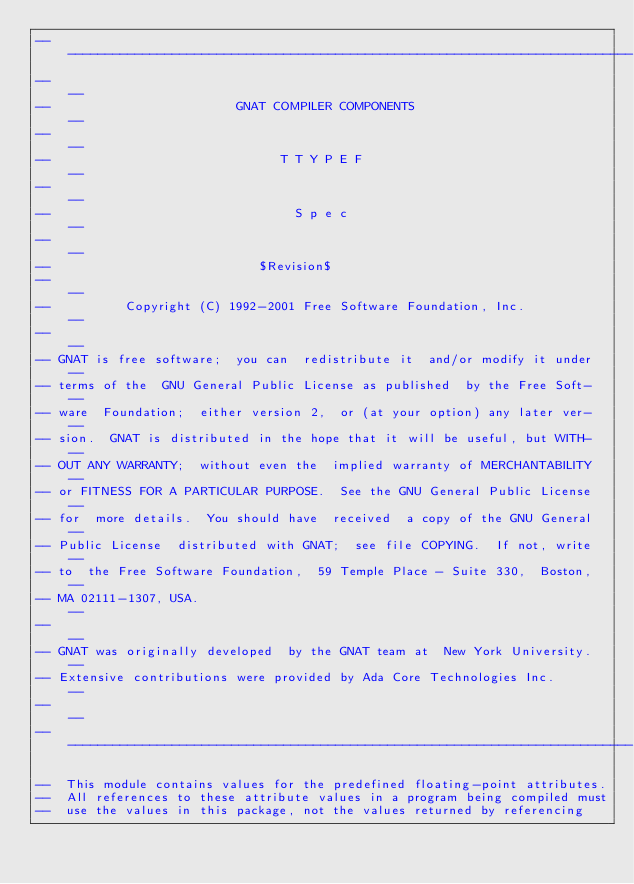<code> <loc_0><loc_0><loc_500><loc_500><_Ada_>------------------------------------------------------------------------------
--                                                                          --
--                         GNAT COMPILER COMPONENTS                         --
--                                                                          --
--                               T T Y P E F                                --
--                                                                          --
--                                 S p e c                                  --
--                                                                          --
--                            $Revision$
--                                                                          --
--          Copyright (C) 1992-2001 Free Software Foundation, Inc.          --
--                                                                          --
-- GNAT is free software;  you can  redistribute it  and/or modify it under --
-- terms of the  GNU General Public License as published  by the Free Soft- --
-- ware  Foundation;  either version 2,  or (at your option) any later ver- --
-- sion.  GNAT is distributed in the hope that it will be useful, but WITH- --
-- OUT ANY WARRANTY;  without even the  implied warranty of MERCHANTABILITY --
-- or FITNESS FOR A PARTICULAR PURPOSE.  See the GNU General Public License --
-- for  more details.  You should have  received  a copy of the GNU General --
-- Public License  distributed with GNAT;  see file COPYING.  If not, write --
-- to  the Free Software Foundation,  59 Temple Place - Suite 330,  Boston, --
-- MA 02111-1307, USA.                                                      --
--                                                                          --
-- GNAT was originally developed  by the GNAT team at  New York University. --
-- Extensive contributions were provided by Ada Core Technologies Inc.      --
--                                                                          --
------------------------------------------------------------------------------

--  This module contains values for the predefined floating-point attributes.
--  All references to these attribute values in a program being compiled must
--  use the values in this package, not the values returned by referencing</code> 